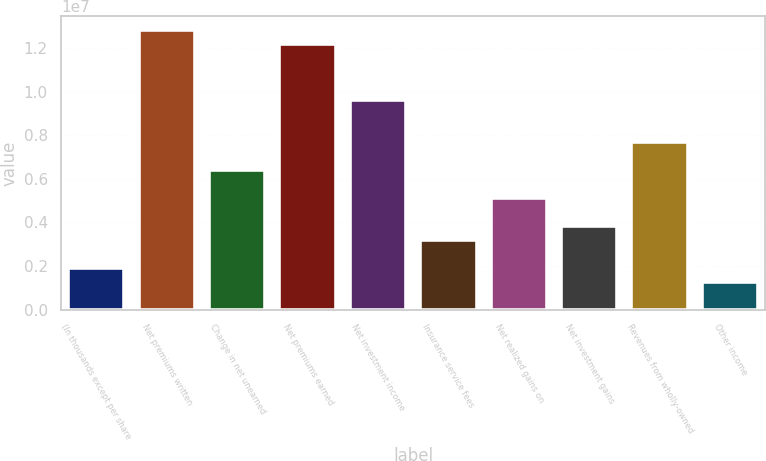Convert chart to OTSL. <chart><loc_0><loc_0><loc_500><loc_500><bar_chart><fcel>(In thousands except per share<fcel>Net premiums written<fcel>Change in net unearned<fcel>Net premiums earned<fcel>Net investment income<fcel>Insurance service fees<fcel>Net realized gains on<fcel>Net investment gains<fcel>Revenues from wholly-owned<fcel>Other income<nl><fcel>1.92256e+06<fcel>1.28171e+07<fcel>6.40853e+06<fcel>1.21762e+07<fcel>9.6128e+06<fcel>3.20427e+06<fcel>5.12683e+06<fcel>3.84512e+06<fcel>7.69024e+06<fcel>1.28171e+06<nl></chart> 